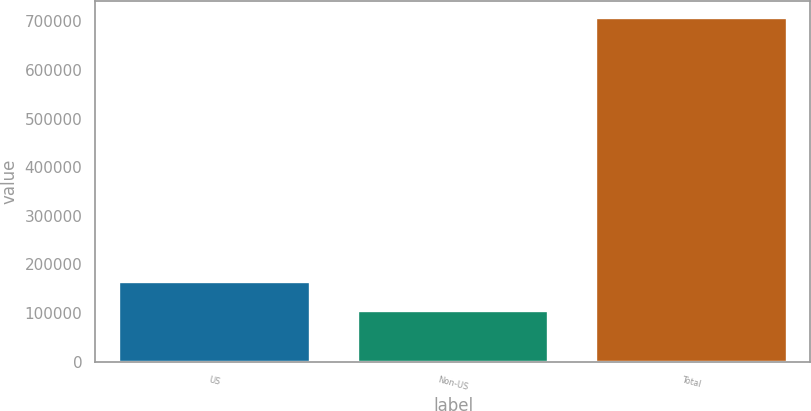<chart> <loc_0><loc_0><loc_500><loc_500><bar_chart><fcel>US<fcel>Non-US<fcel>Total<nl><fcel>164063<fcel>103774<fcel>706668<nl></chart> 